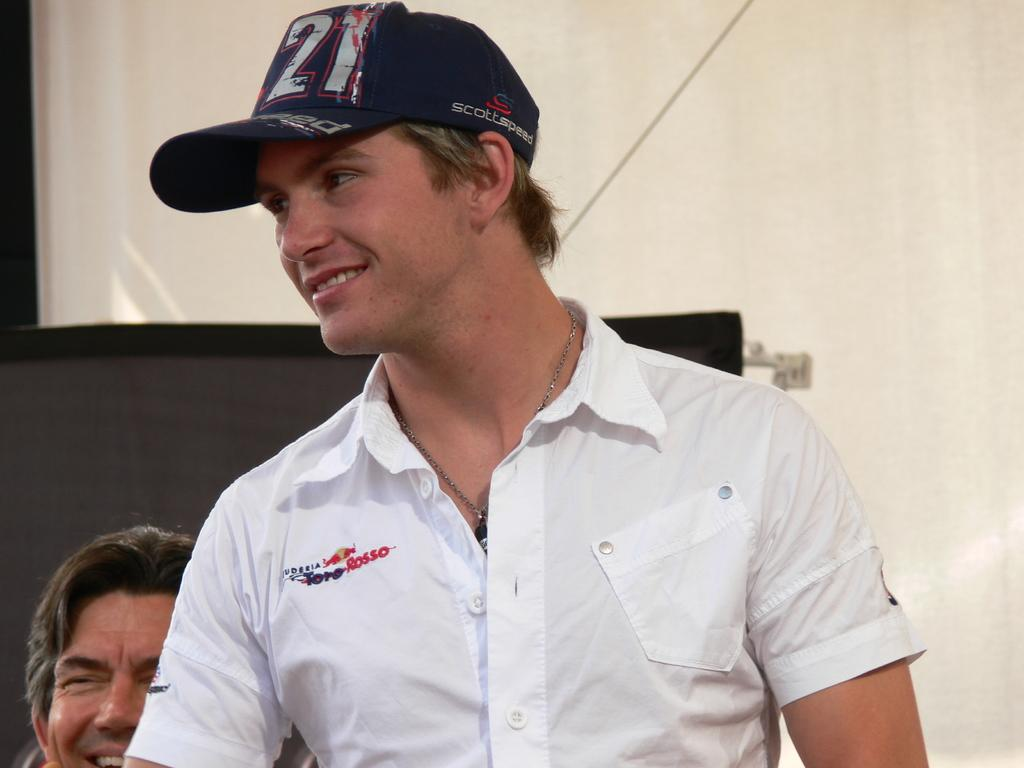<image>
Give a short and clear explanation of the subsequent image. smiling guy wearing cap with 21 on it ans shirt with toro rosso logo 